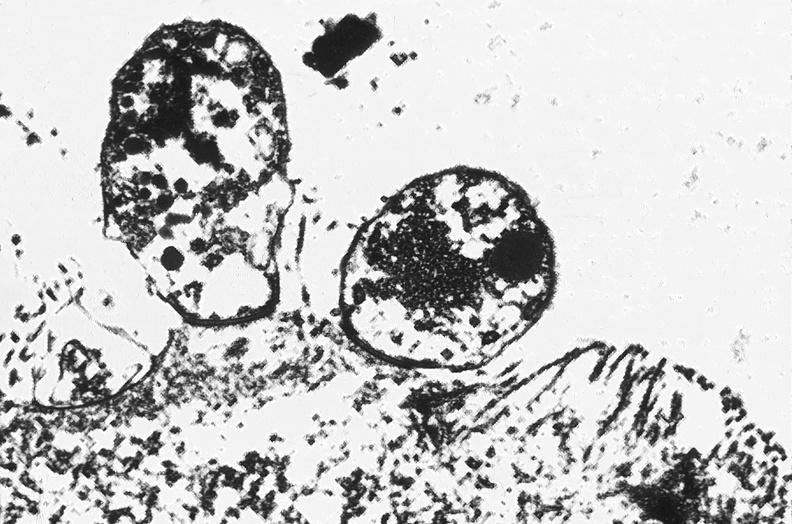what is present?
Answer the question using a single word or phrase. Gastrointestinal 